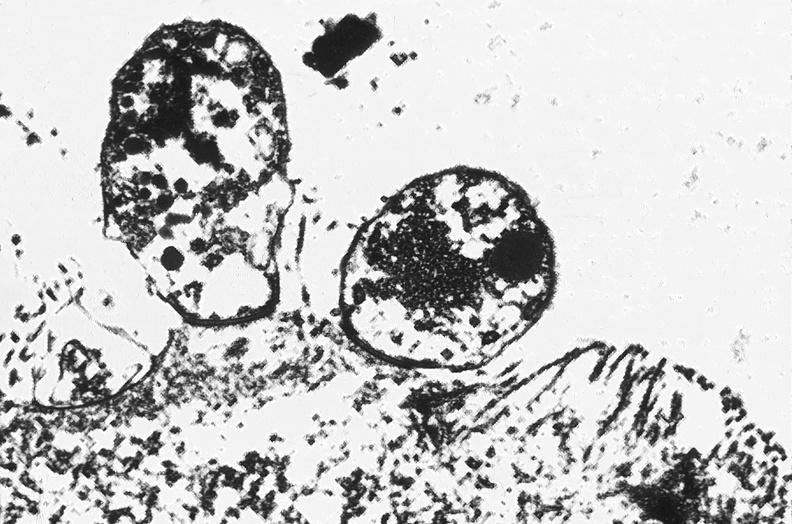what is present?
Answer the question using a single word or phrase. Gastrointestinal 